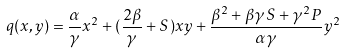Convert formula to latex. <formula><loc_0><loc_0><loc_500><loc_500>q ( x , y ) = \frac { \alpha } { \gamma } x ^ { 2 } + ( \frac { 2 \beta } { \gamma } + S ) x y + \frac { \beta ^ { 2 } + \beta \gamma S + \gamma ^ { 2 } P } { \alpha \gamma } y ^ { 2 }</formula> 